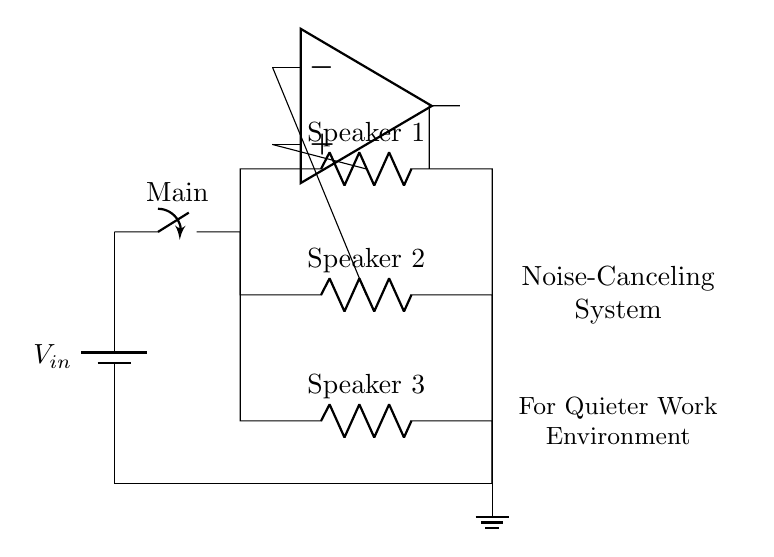What is the main function of the op-amp in this circuit? The op-amp serves as a noise cancellation control, helping to minimize unwanted sound interference by processing the audio signals from the speakers.
Answer: noise cancellation control How many speakers are connected in the circuit? There are three speakers connected in parallel branches from the main switch, each connected to the voltage supply.
Answer: three What is the role of the main switch? The main switch acts as a control mechanism that allows or interrupts power supply to the entire circuit, enabling or disabling the operation of the noise-canceling system.
Answer: control mechanism What type of circuit configuration is used for the speakers? The speakers are connected in parallel, allowing each speaker to receive the same voltage while operating independently on the circuit.
Answer: parallel What is the voltage supply for this circuit? The exact voltage value isn't provided in the circuit diagram. However, the voltage supply is indicated as Vin, which signifies an external power source essential for operating the system.
Answer: Vin 